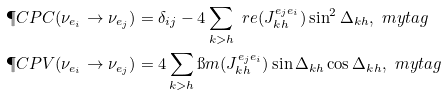Convert formula to latex. <formula><loc_0><loc_0><loc_500><loc_500>\P C P C ( \nu _ { e _ { i } } \rightarrow \nu _ { e _ { j } } ) & = \delta _ { i j } - 4 \sum _ { k > h } \ r e ( J ^ { e _ { j } e _ { i } } _ { k h } ) \sin ^ { 2 } \Delta _ { k h } , \ m y t a g \\ \P C P V ( \nu _ { e _ { i } } \rightarrow \nu _ { e _ { j } } ) & = 4 \sum _ { k > h } \i m ( J ^ { e _ { j } e _ { i } } _ { k h } ) \sin \Delta _ { k h } \cos \Delta _ { k h } , \ m y t a g</formula> 